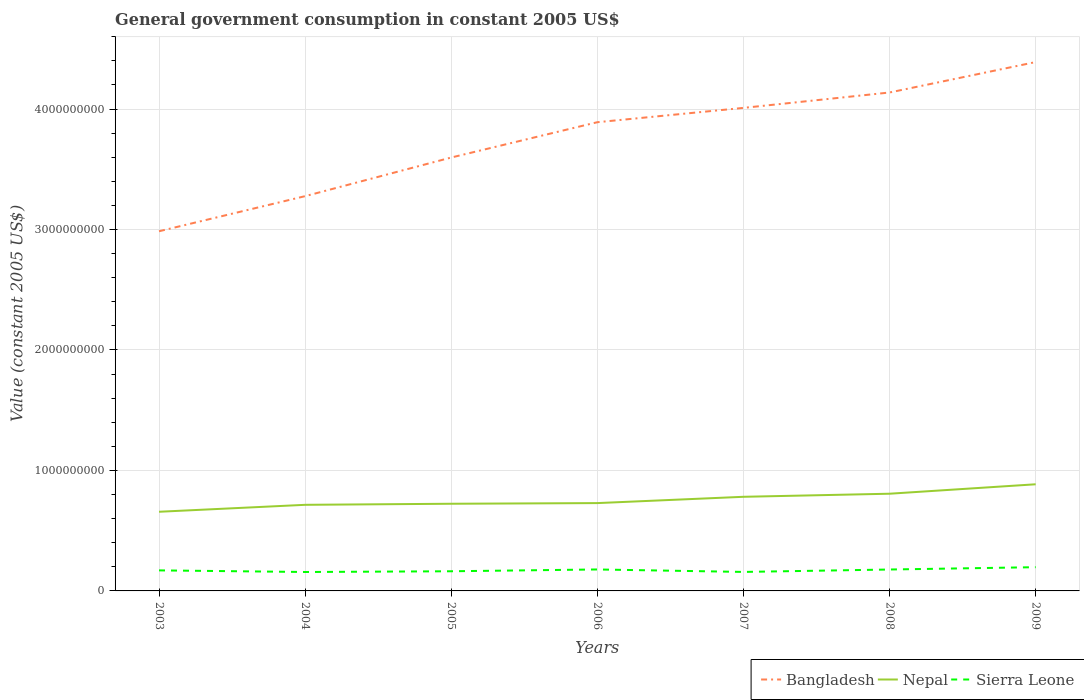Does the line corresponding to Bangladesh intersect with the line corresponding to Nepal?
Make the answer very short. No. Is the number of lines equal to the number of legend labels?
Your answer should be very brief. Yes. Across all years, what is the maximum government conusmption in Nepal?
Provide a succinct answer. 6.57e+08. In which year was the government conusmption in Sierra Leone maximum?
Your answer should be very brief. 2004. What is the total government conusmption in Sierra Leone in the graph?
Provide a succinct answer. -2.06e+07. What is the difference between the highest and the second highest government conusmption in Bangladesh?
Provide a short and direct response. 1.40e+09. Are the values on the major ticks of Y-axis written in scientific E-notation?
Make the answer very short. No. Does the graph contain any zero values?
Your answer should be very brief. No. Does the graph contain grids?
Your answer should be compact. Yes. Where does the legend appear in the graph?
Ensure brevity in your answer.  Bottom right. How many legend labels are there?
Make the answer very short. 3. What is the title of the graph?
Make the answer very short. General government consumption in constant 2005 US$. Does "Norway" appear as one of the legend labels in the graph?
Offer a terse response. No. What is the label or title of the X-axis?
Your answer should be very brief. Years. What is the label or title of the Y-axis?
Offer a very short reply. Value (constant 2005 US$). What is the Value (constant 2005 US$) of Bangladesh in 2003?
Give a very brief answer. 2.99e+09. What is the Value (constant 2005 US$) in Nepal in 2003?
Offer a terse response. 6.57e+08. What is the Value (constant 2005 US$) of Sierra Leone in 2003?
Your response must be concise. 1.70e+08. What is the Value (constant 2005 US$) in Bangladesh in 2004?
Ensure brevity in your answer.  3.28e+09. What is the Value (constant 2005 US$) of Nepal in 2004?
Give a very brief answer. 7.15e+08. What is the Value (constant 2005 US$) of Sierra Leone in 2004?
Offer a very short reply. 1.57e+08. What is the Value (constant 2005 US$) in Bangladesh in 2005?
Your answer should be compact. 3.60e+09. What is the Value (constant 2005 US$) in Nepal in 2005?
Ensure brevity in your answer.  7.24e+08. What is the Value (constant 2005 US$) of Sierra Leone in 2005?
Your response must be concise. 1.63e+08. What is the Value (constant 2005 US$) of Bangladesh in 2006?
Give a very brief answer. 3.89e+09. What is the Value (constant 2005 US$) of Nepal in 2006?
Offer a very short reply. 7.29e+08. What is the Value (constant 2005 US$) in Sierra Leone in 2006?
Offer a very short reply. 1.78e+08. What is the Value (constant 2005 US$) in Bangladesh in 2007?
Provide a succinct answer. 4.01e+09. What is the Value (constant 2005 US$) in Nepal in 2007?
Ensure brevity in your answer.  7.81e+08. What is the Value (constant 2005 US$) in Sierra Leone in 2007?
Your answer should be compact. 1.58e+08. What is the Value (constant 2005 US$) of Bangladesh in 2008?
Make the answer very short. 4.14e+09. What is the Value (constant 2005 US$) of Nepal in 2008?
Keep it short and to the point. 8.07e+08. What is the Value (constant 2005 US$) in Sierra Leone in 2008?
Your answer should be very brief. 1.78e+08. What is the Value (constant 2005 US$) in Bangladesh in 2009?
Your answer should be very brief. 4.39e+09. What is the Value (constant 2005 US$) of Nepal in 2009?
Your answer should be very brief. 8.85e+08. What is the Value (constant 2005 US$) of Sierra Leone in 2009?
Your response must be concise. 1.97e+08. Across all years, what is the maximum Value (constant 2005 US$) in Bangladesh?
Give a very brief answer. 4.39e+09. Across all years, what is the maximum Value (constant 2005 US$) in Nepal?
Provide a succinct answer. 8.85e+08. Across all years, what is the maximum Value (constant 2005 US$) of Sierra Leone?
Your answer should be very brief. 1.97e+08. Across all years, what is the minimum Value (constant 2005 US$) in Bangladesh?
Your answer should be compact. 2.99e+09. Across all years, what is the minimum Value (constant 2005 US$) in Nepal?
Give a very brief answer. 6.57e+08. Across all years, what is the minimum Value (constant 2005 US$) in Sierra Leone?
Provide a succinct answer. 1.57e+08. What is the total Value (constant 2005 US$) in Bangladesh in the graph?
Your response must be concise. 2.63e+1. What is the total Value (constant 2005 US$) of Nepal in the graph?
Ensure brevity in your answer.  5.30e+09. What is the total Value (constant 2005 US$) in Sierra Leone in the graph?
Ensure brevity in your answer.  1.20e+09. What is the difference between the Value (constant 2005 US$) in Bangladesh in 2003 and that in 2004?
Provide a succinct answer. -2.91e+08. What is the difference between the Value (constant 2005 US$) in Nepal in 2003 and that in 2004?
Provide a succinct answer. -5.77e+07. What is the difference between the Value (constant 2005 US$) in Sierra Leone in 2003 and that in 2004?
Your response must be concise. 1.34e+07. What is the difference between the Value (constant 2005 US$) in Bangladesh in 2003 and that in 2005?
Give a very brief answer. -6.12e+08. What is the difference between the Value (constant 2005 US$) in Nepal in 2003 and that in 2005?
Offer a very short reply. -6.66e+07. What is the difference between the Value (constant 2005 US$) of Sierra Leone in 2003 and that in 2005?
Ensure brevity in your answer.  7.30e+06. What is the difference between the Value (constant 2005 US$) in Bangladesh in 2003 and that in 2006?
Offer a terse response. -9.05e+08. What is the difference between the Value (constant 2005 US$) of Nepal in 2003 and that in 2006?
Your answer should be compact. -7.20e+07. What is the difference between the Value (constant 2005 US$) in Sierra Leone in 2003 and that in 2006?
Your answer should be very brief. -7.66e+06. What is the difference between the Value (constant 2005 US$) in Bangladesh in 2003 and that in 2007?
Ensure brevity in your answer.  -1.02e+09. What is the difference between the Value (constant 2005 US$) in Nepal in 2003 and that in 2007?
Your response must be concise. -1.24e+08. What is the difference between the Value (constant 2005 US$) in Sierra Leone in 2003 and that in 2007?
Offer a terse response. 1.28e+07. What is the difference between the Value (constant 2005 US$) of Bangladesh in 2003 and that in 2008?
Ensure brevity in your answer.  -1.15e+09. What is the difference between the Value (constant 2005 US$) in Nepal in 2003 and that in 2008?
Your answer should be compact. -1.50e+08. What is the difference between the Value (constant 2005 US$) in Sierra Leone in 2003 and that in 2008?
Provide a succinct answer. -7.21e+06. What is the difference between the Value (constant 2005 US$) in Bangladesh in 2003 and that in 2009?
Offer a terse response. -1.40e+09. What is the difference between the Value (constant 2005 US$) in Nepal in 2003 and that in 2009?
Offer a terse response. -2.28e+08. What is the difference between the Value (constant 2005 US$) in Sierra Leone in 2003 and that in 2009?
Make the answer very short. -2.65e+07. What is the difference between the Value (constant 2005 US$) of Bangladesh in 2004 and that in 2005?
Offer a very short reply. -3.21e+08. What is the difference between the Value (constant 2005 US$) in Nepal in 2004 and that in 2005?
Keep it short and to the point. -8.87e+06. What is the difference between the Value (constant 2005 US$) in Sierra Leone in 2004 and that in 2005?
Your answer should be compact. -6.08e+06. What is the difference between the Value (constant 2005 US$) in Bangladesh in 2004 and that in 2006?
Your answer should be compact. -6.14e+08. What is the difference between the Value (constant 2005 US$) in Nepal in 2004 and that in 2006?
Provide a short and direct response. -1.43e+07. What is the difference between the Value (constant 2005 US$) of Sierra Leone in 2004 and that in 2006?
Ensure brevity in your answer.  -2.11e+07. What is the difference between the Value (constant 2005 US$) of Bangladesh in 2004 and that in 2007?
Offer a terse response. -7.33e+08. What is the difference between the Value (constant 2005 US$) of Nepal in 2004 and that in 2007?
Offer a terse response. -6.66e+07. What is the difference between the Value (constant 2005 US$) of Sierra Leone in 2004 and that in 2007?
Give a very brief answer. -5.56e+05. What is the difference between the Value (constant 2005 US$) of Bangladesh in 2004 and that in 2008?
Provide a succinct answer. -8.60e+08. What is the difference between the Value (constant 2005 US$) of Nepal in 2004 and that in 2008?
Ensure brevity in your answer.  -9.21e+07. What is the difference between the Value (constant 2005 US$) in Sierra Leone in 2004 and that in 2008?
Give a very brief answer. -2.06e+07. What is the difference between the Value (constant 2005 US$) in Bangladesh in 2004 and that in 2009?
Offer a very short reply. -1.11e+09. What is the difference between the Value (constant 2005 US$) of Nepal in 2004 and that in 2009?
Ensure brevity in your answer.  -1.70e+08. What is the difference between the Value (constant 2005 US$) in Sierra Leone in 2004 and that in 2009?
Keep it short and to the point. -3.99e+07. What is the difference between the Value (constant 2005 US$) in Bangladesh in 2005 and that in 2006?
Keep it short and to the point. -2.93e+08. What is the difference between the Value (constant 2005 US$) of Nepal in 2005 and that in 2006?
Your answer should be compact. -5.47e+06. What is the difference between the Value (constant 2005 US$) of Sierra Leone in 2005 and that in 2006?
Provide a short and direct response. -1.50e+07. What is the difference between the Value (constant 2005 US$) of Bangladesh in 2005 and that in 2007?
Ensure brevity in your answer.  -4.12e+08. What is the difference between the Value (constant 2005 US$) of Nepal in 2005 and that in 2007?
Your response must be concise. -5.77e+07. What is the difference between the Value (constant 2005 US$) in Sierra Leone in 2005 and that in 2007?
Provide a succinct answer. 5.53e+06. What is the difference between the Value (constant 2005 US$) of Bangladesh in 2005 and that in 2008?
Provide a succinct answer. -5.40e+08. What is the difference between the Value (constant 2005 US$) of Nepal in 2005 and that in 2008?
Give a very brief answer. -8.33e+07. What is the difference between the Value (constant 2005 US$) in Sierra Leone in 2005 and that in 2008?
Provide a short and direct response. -1.45e+07. What is the difference between the Value (constant 2005 US$) of Bangladesh in 2005 and that in 2009?
Your answer should be very brief. -7.92e+08. What is the difference between the Value (constant 2005 US$) of Nepal in 2005 and that in 2009?
Offer a very short reply. -1.62e+08. What is the difference between the Value (constant 2005 US$) in Sierra Leone in 2005 and that in 2009?
Ensure brevity in your answer.  -3.38e+07. What is the difference between the Value (constant 2005 US$) in Bangladesh in 2006 and that in 2007?
Give a very brief answer. -1.19e+08. What is the difference between the Value (constant 2005 US$) of Nepal in 2006 and that in 2007?
Ensure brevity in your answer.  -5.22e+07. What is the difference between the Value (constant 2005 US$) of Sierra Leone in 2006 and that in 2007?
Keep it short and to the point. 2.05e+07. What is the difference between the Value (constant 2005 US$) of Bangladesh in 2006 and that in 2008?
Give a very brief answer. -2.47e+08. What is the difference between the Value (constant 2005 US$) of Nepal in 2006 and that in 2008?
Keep it short and to the point. -7.78e+07. What is the difference between the Value (constant 2005 US$) in Sierra Leone in 2006 and that in 2008?
Offer a terse response. 4.51e+05. What is the difference between the Value (constant 2005 US$) of Bangladesh in 2006 and that in 2009?
Provide a short and direct response. -4.99e+08. What is the difference between the Value (constant 2005 US$) of Nepal in 2006 and that in 2009?
Give a very brief answer. -1.56e+08. What is the difference between the Value (constant 2005 US$) of Sierra Leone in 2006 and that in 2009?
Your response must be concise. -1.89e+07. What is the difference between the Value (constant 2005 US$) of Bangladesh in 2007 and that in 2008?
Provide a succinct answer. -1.28e+08. What is the difference between the Value (constant 2005 US$) of Nepal in 2007 and that in 2008?
Make the answer very short. -2.56e+07. What is the difference between the Value (constant 2005 US$) in Sierra Leone in 2007 and that in 2008?
Offer a terse response. -2.00e+07. What is the difference between the Value (constant 2005 US$) of Bangladesh in 2007 and that in 2009?
Offer a terse response. -3.80e+08. What is the difference between the Value (constant 2005 US$) of Nepal in 2007 and that in 2009?
Your answer should be very brief. -1.04e+08. What is the difference between the Value (constant 2005 US$) of Sierra Leone in 2007 and that in 2009?
Your answer should be very brief. -3.93e+07. What is the difference between the Value (constant 2005 US$) of Bangladesh in 2008 and that in 2009?
Your answer should be very brief. -2.52e+08. What is the difference between the Value (constant 2005 US$) in Nepal in 2008 and that in 2009?
Your answer should be very brief. -7.83e+07. What is the difference between the Value (constant 2005 US$) of Sierra Leone in 2008 and that in 2009?
Ensure brevity in your answer.  -1.93e+07. What is the difference between the Value (constant 2005 US$) in Bangladesh in 2003 and the Value (constant 2005 US$) in Nepal in 2004?
Offer a terse response. 2.27e+09. What is the difference between the Value (constant 2005 US$) of Bangladesh in 2003 and the Value (constant 2005 US$) of Sierra Leone in 2004?
Provide a short and direct response. 2.83e+09. What is the difference between the Value (constant 2005 US$) in Nepal in 2003 and the Value (constant 2005 US$) in Sierra Leone in 2004?
Your answer should be compact. 5.00e+08. What is the difference between the Value (constant 2005 US$) of Bangladesh in 2003 and the Value (constant 2005 US$) of Nepal in 2005?
Make the answer very short. 2.26e+09. What is the difference between the Value (constant 2005 US$) of Bangladesh in 2003 and the Value (constant 2005 US$) of Sierra Leone in 2005?
Your answer should be very brief. 2.82e+09. What is the difference between the Value (constant 2005 US$) of Nepal in 2003 and the Value (constant 2005 US$) of Sierra Leone in 2005?
Provide a succinct answer. 4.94e+08. What is the difference between the Value (constant 2005 US$) in Bangladesh in 2003 and the Value (constant 2005 US$) in Nepal in 2006?
Offer a terse response. 2.26e+09. What is the difference between the Value (constant 2005 US$) in Bangladesh in 2003 and the Value (constant 2005 US$) in Sierra Leone in 2006?
Offer a terse response. 2.81e+09. What is the difference between the Value (constant 2005 US$) in Nepal in 2003 and the Value (constant 2005 US$) in Sierra Leone in 2006?
Give a very brief answer. 4.79e+08. What is the difference between the Value (constant 2005 US$) of Bangladesh in 2003 and the Value (constant 2005 US$) of Nepal in 2007?
Your answer should be very brief. 2.20e+09. What is the difference between the Value (constant 2005 US$) in Bangladesh in 2003 and the Value (constant 2005 US$) in Sierra Leone in 2007?
Ensure brevity in your answer.  2.83e+09. What is the difference between the Value (constant 2005 US$) in Nepal in 2003 and the Value (constant 2005 US$) in Sierra Leone in 2007?
Make the answer very short. 4.99e+08. What is the difference between the Value (constant 2005 US$) in Bangladesh in 2003 and the Value (constant 2005 US$) in Nepal in 2008?
Provide a short and direct response. 2.18e+09. What is the difference between the Value (constant 2005 US$) of Bangladesh in 2003 and the Value (constant 2005 US$) of Sierra Leone in 2008?
Keep it short and to the point. 2.81e+09. What is the difference between the Value (constant 2005 US$) in Nepal in 2003 and the Value (constant 2005 US$) in Sierra Leone in 2008?
Provide a succinct answer. 4.79e+08. What is the difference between the Value (constant 2005 US$) in Bangladesh in 2003 and the Value (constant 2005 US$) in Nepal in 2009?
Your answer should be very brief. 2.10e+09. What is the difference between the Value (constant 2005 US$) of Bangladesh in 2003 and the Value (constant 2005 US$) of Sierra Leone in 2009?
Make the answer very short. 2.79e+09. What is the difference between the Value (constant 2005 US$) of Nepal in 2003 and the Value (constant 2005 US$) of Sierra Leone in 2009?
Your answer should be compact. 4.60e+08. What is the difference between the Value (constant 2005 US$) in Bangladesh in 2004 and the Value (constant 2005 US$) in Nepal in 2005?
Provide a succinct answer. 2.55e+09. What is the difference between the Value (constant 2005 US$) in Bangladesh in 2004 and the Value (constant 2005 US$) in Sierra Leone in 2005?
Offer a terse response. 3.11e+09. What is the difference between the Value (constant 2005 US$) in Nepal in 2004 and the Value (constant 2005 US$) in Sierra Leone in 2005?
Ensure brevity in your answer.  5.51e+08. What is the difference between the Value (constant 2005 US$) in Bangladesh in 2004 and the Value (constant 2005 US$) in Nepal in 2006?
Give a very brief answer. 2.55e+09. What is the difference between the Value (constant 2005 US$) in Bangladesh in 2004 and the Value (constant 2005 US$) in Sierra Leone in 2006?
Provide a succinct answer. 3.10e+09. What is the difference between the Value (constant 2005 US$) of Nepal in 2004 and the Value (constant 2005 US$) of Sierra Leone in 2006?
Your answer should be very brief. 5.37e+08. What is the difference between the Value (constant 2005 US$) of Bangladesh in 2004 and the Value (constant 2005 US$) of Nepal in 2007?
Ensure brevity in your answer.  2.50e+09. What is the difference between the Value (constant 2005 US$) in Bangladesh in 2004 and the Value (constant 2005 US$) in Sierra Leone in 2007?
Provide a succinct answer. 3.12e+09. What is the difference between the Value (constant 2005 US$) in Nepal in 2004 and the Value (constant 2005 US$) in Sierra Leone in 2007?
Keep it short and to the point. 5.57e+08. What is the difference between the Value (constant 2005 US$) of Bangladesh in 2004 and the Value (constant 2005 US$) of Nepal in 2008?
Make the answer very short. 2.47e+09. What is the difference between the Value (constant 2005 US$) of Bangladesh in 2004 and the Value (constant 2005 US$) of Sierra Leone in 2008?
Your answer should be very brief. 3.10e+09. What is the difference between the Value (constant 2005 US$) of Nepal in 2004 and the Value (constant 2005 US$) of Sierra Leone in 2008?
Your answer should be compact. 5.37e+08. What is the difference between the Value (constant 2005 US$) of Bangladesh in 2004 and the Value (constant 2005 US$) of Nepal in 2009?
Ensure brevity in your answer.  2.39e+09. What is the difference between the Value (constant 2005 US$) of Bangladesh in 2004 and the Value (constant 2005 US$) of Sierra Leone in 2009?
Ensure brevity in your answer.  3.08e+09. What is the difference between the Value (constant 2005 US$) of Nepal in 2004 and the Value (constant 2005 US$) of Sierra Leone in 2009?
Ensure brevity in your answer.  5.18e+08. What is the difference between the Value (constant 2005 US$) in Bangladesh in 2005 and the Value (constant 2005 US$) in Nepal in 2006?
Your response must be concise. 2.87e+09. What is the difference between the Value (constant 2005 US$) of Bangladesh in 2005 and the Value (constant 2005 US$) of Sierra Leone in 2006?
Your answer should be compact. 3.42e+09. What is the difference between the Value (constant 2005 US$) in Nepal in 2005 and the Value (constant 2005 US$) in Sierra Leone in 2006?
Keep it short and to the point. 5.45e+08. What is the difference between the Value (constant 2005 US$) in Bangladesh in 2005 and the Value (constant 2005 US$) in Nepal in 2007?
Provide a short and direct response. 2.82e+09. What is the difference between the Value (constant 2005 US$) in Bangladesh in 2005 and the Value (constant 2005 US$) in Sierra Leone in 2007?
Provide a short and direct response. 3.44e+09. What is the difference between the Value (constant 2005 US$) in Nepal in 2005 and the Value (constant 2005 US$) in Sierra Leone in 2007?
Make the answer very short. 5.66e+08. What is the difference between the Value (constant 2005 US$) of Bangladesh in 2005 and the Value (constant 2005 US$) of Nepal in 2008?
Provide a succinct answer. 2.79e+09. What is the difference between the Value (constant 2005 US$) of Bangladesh in 2005 and the Value (constant 2005 US$) of Sierra Leone in 2008?
Your response must be concise. 3.42e+09. What is the difference between the Value (constant 2005 US$) of Nepal in 2005 and the Value (constant 2005 US$) of Sierra Leone in 2008?
Give a very brief answer. 5.46e+08. What is the difference between the Value (constant 2005 US$) in Bangladesh in 2005 and the Value (constant 2005 US$) in Nepal in 2009?
Make the answer very short. 2.71e+09. What is the difference between the Value (constant 2005 US$) of Bangladesh in 2005 and the Value (constant 2005 US$) of Sierra Leone in 2009?
Make the answer very short. 3.40e+09. What is the difference between the Value (constant 2005 US$) in Nepal in 2005 and the Value (constant 2005 US$) in Sierra Leone in 2009?
Offer a very short reply. 5.27e+08. What is the difference between the Value (constant 2005 US$) in Bangladesh in 2006 and the Value (constant 2005 US$) in Nepal in 2007?
Provide a succinct answer. 3.11e+09. What is the difference between the Value (constant 2005 US$) in Bangladesh in 2006 and the Value (constant 2005 US$) in Sierra Leone in 2007?
Offer a very short reply. 3.73e+09. What is the difference between the Value (constant 2005 US$) in Nepal in 2006 and the Value (constant 2005 US$) in Sierra Leone in 2007?
Your answer should be very brief. 5.71e+08. What is the difference between the Value (constant 2005 US$) of Bangladesh in 2006 and the Value (constant 2005 US$) of Nepal in 2008?
Provide a short and direct response. 3.08e+09. What is the difference between the Value (constant 2005 US$) in Bangladesh in 2006 and the Value (constant 2005 US$) in Sierra Leone in 2008?
Keep it short and to the point. 3.71e+09. What is the difference between the Value (constant 2005 US$) of Nepal in 2006 and the Value (constant 2005 US$) of Sierra Leone in 2008?
Your answer should be very brief. 5.51e+08. What is the difference between the Value (constant 2005 US$) of Bangladesh in 2006 and the Value (constant 2005 US$) of Nepal in 2009?
Your response must be concise. 3.01e+09. What is the difference between the Value (constant 2005 US$) in Bangladesh in 2006 and the Value (constant 2005 US$) in Sierra Leone in 2009?
Ensure brevity in your answer.  3.69e+09. What is the difference between the Value (constant 2005 US$) in Nepal in 2006 and the Value (constant 2005 US$) in Sierra Leone in 2009?
Your answer should be compact. 5.32e+08. What is the difference between the Value (constant 2005 US$) in Bangladesh in 2007 and the Value (constant 2005 US$) in Nepal in 2008?
Your answer should be very brief. 3.20e+09. What is the difference between the Value (constant 2005 US$) in Bangladesh in 2007 and the Value (constant 2005 US$) in Sierra Leone in 2008?
Ensure brevity in your answer.  3.83e+09. What is the difference between the Value (constant 2005 US$) of Nepal in 2007 and the Value (constant 2005 US$) of Sierra Leone in 2008?
Provide a short and direct response. 6.04e+08. What is the difference between the Value (constant 2005 US$) of Bangladesh in 2007 and the Value (constant 2005 US$) of Nepal in 2009?
Provide a short and direct response. 3.12e+09. What is the difference between the Value (constant 2005 US$) of Bangladesh in 2007 and the Value (constant 2005 US$) of Sierra Leone in 2009?
Make the answer very short. 3.81e+09. What is the difference between the Value (constant 2005 US$) in Nepal in 2007 and the Value (constant 2005 US$) in Sierra Leone in 2009?
Make the answer very short. 5.84e+08. What is the difference between the Value (constant 2005 US$) in Bangladesh in 2008 and the Value (constant 2005 US$) in Nepal in 2009?
Provide a succinct answer. 3.25e+09. What is the difference between the Value (constant 2005 US$) of Bangladesh in 2008 and the Value (constant 2005 US$) of Sierra Leone in 2009?
Give a very brief answer. 3.94e+09. What is the difference between the Value (constant 2005 US$) in Nepal in 2008 and the Value (constant 2005 US$) in Sierra Leone in 2009?
Provide a short and direct response. 6.10e+08. What is the average Value (constant 2005 US$) in Bangladesh per year?
Your response must be concise. 3.76e+09. What is the average Value (constant 2005 US$) in Nepal per year?
Your answer should be compact. 7.57e+08. What is the average Value (constant 2005 US$) of Sierra Leone per year?
Your answer should be compact. 1.72e+08. In the year 2003, what is the difference between the Value (constant 2005 US$) of Bangladesh and Value (constant 2005 US$) of Nepal?
Your answer should be compact. 2.33e+09. In the year 2003, what is the difference between the Value (constant 2005 US$) in Bangladesh and Value (constant 2005 US$) in Sierra Leone?
Provide a succinct answer. 2.81e+09. In the year 2003, what is the difference between the Value (constant 2005 US$) of Nepal and Value (constant 2005 US$) of Sierra Leone?
Give a very brief answer. 4.86e+08. In the year 2004, what is the difference between the Value (constant 2005 US$) in Bangladesh and Value (constant 2005 US$) in Nepal?
Your response must be concise. 2.56e+09. In the year 2004, what is the difference between the Value (constant 2005 US$) of Bangladesh and Value (constant 2005 US$) of Sierra Leone?
Make the answer very short. 3.12e+09. In the year 2004, what is the difference between the Value (constant 2005 US$) of Nepal and Value (constant 2005 US$) of Sierra Leone?
Your response must be concise. 5.58e+08. In the year 2005, what is the difference between the Value (constant 2005 US$) of Bangladesh and Value (constant 2005 US$) of Nepal?
Give a very brief answer. 2.87e+09. In the year 2005, what is the difference between the Value (constant 2005 US$) of Bangladesh and Value (constant 2005 US$) of Sierra Leone?
Your answer should be very brief. 3.43e+09. In the year 2005, what is the difference between the Value (constant 2005 US$) of Nepal and Value (constant 2005 US$) of Sierra Leone?
Your answer should be compact. 5.60e+08. In the year 2006, what is the difference between the Value (constant 2005 US$) of Bangladesh and Value (constant 2005 US$) of Nepal?
Ensure brevity in your answer.  3.16e+09. In the year 2006, what is the difference between the Value (constant 2005 US$) in Bangladesh and Value (constant 2005 US$) in Sierra Leone?
Ensure brevity in your answer.  3.71e+09. In the year 2006, what is the difference between the Value (constant 2005 US$) in Nepal and Value (constant 2005 US$) in Sierra Leone?
Provide a succinct answer. 5.51e+08. In the year 2007, what is the difference between the Value (constant 2005 US$) of Bangladesh and Value (constant 2005 US$) of Nepal?
Make the answer very short. 3.23e+09. In the year 2007, what is the difference between the Value (constant 2005 US$) of Bangladesh and Value (constant 2005 US$) of Sierra Leone?
Your answer should be very brief. 3.85e+09. In the year 2007, what is the difference between the Value (constant 2005 US$) of Nepal and Value (constant 2005 US$) of Sierra Leone?
Offer a very short reply. 6.24e+08. In the year 2008, what is the difference between the Value (constant 2005 US$) of Bangladesh and Value (constant 2005 US$) of Nepal?
Offer a terse response. 3.33e+09. In the year 2008, what is the difference between the Value (constant 2005 US$) in Bangladesh and Value (constant 2005 US$) in Sierra Leone?
Offer a very short reply. 3.96e+09. In the year 2008, what is the difference between the Value (constant 2005 US$) in Nepal and Value (constant 2005 US$) in Sierra Leone?
Provide a succinct answer. 6.29e+08. In the year 2009, what is the difference between the Value (constant 2005 US$) of Bangladesh and Value (constant 2005 US$) of Nepal?
Provide a short and direct response. 3.50e+09. In the year 2009, what is the difference between the Value (constant 2005 US$) in Bangladesh and Value (constant 2005 US$) in Sierra Leone?
Make the answer very short. 4.19e+09. In the year 2009, what is the difference between the Value (constant 2005 US$) of Nepal and Value (constant 2005 US$) of Sierra Leone?
Ensure brevity in your answer.  6.88e+08. What is the ratio of the Value (constant 2005 US$) in Bangladesh in 2003 to that in 2004?
Offer a very short reply. 0.91. What is the ratio of the Value (constant 2005 US$) of Nepal in 2003 to that in 2004?
Provide a succinct answer. 0.92. What is the ratio of the Value (constant 2005 US$) of Sierra Leone in 2003 to that in 2004?
Provide a succinct answer. 1.09. What is the ratio of the Value (constant 2005 US$) in Bangladesh in 2003 to that in 2005?
Offer a very short reply. 0.83. What is the ratio of the Value (constant 2005 US$) in Nepal in 2003 to that in 2005?
Ensure brevity in your answer.  0.91. What is the ratio of the Value (constant 2005 US$) of Sierra Leone in 2003 to that in 2005?
Ensure brevity in your answer.  1.04. What is the ratio of the Value (constant 2005 US$) of Bangladesh in 2003 to that in 2006?
Provide a short and direct response. 0.77. What is the ratio of the Value (constant 2005 US$) in Nepal in 2003 to that in 2006?
Give a very brief answer. 0.9. What is the ratio of the Value (constant 2005 US$) of Sierra Leone in 2003 to that in 2006?
Your answer should be very brief. 0.96. What is the ratio of the Value (constant 2005 US$) in Bangladesh in 2003 to that in 2007?
Your answer should be compact. 0.74. What is the ratio of the Value (constant 2005 US$) of Nepal in 2003 to that in 2007?
Your response must be concise. 0.84. What is the ratio of the Value (constant 2005 US$) of Sierra Leone in 2003 to that in 2007?
Offer a very short reply. 1.08. What is the ratio of the Value (constant 2005 US$) of Bangladesh in 2003 to that in 2008?
Your answer should be very brief. 0.72. What is the ratio of the Value (constant 2005 US$) in Nepal in 2003 to that in 2008?
Offer a very short reply. 0.81. What is the ratio of the Value (constant 2005 US$) of Sierra Leone in 2003 to that in 2008?
Keep it short and to the point. 0.96. What is the ratio of the Value (constant 2005 US$) in Bangladesh in 2003 to that in 2009?
Ensure brevity in your answer.  0.68. What is the ratio of the Value (constant 2005 US$) in Nepal in 2003 to that in 2009?
Your answer should be very brief. 0.74. What is the ratio of the Value (constant 2005 US$) of Sierra Leone in 2003 to that in 2009?
Offer a terse response. 0.87. What is the ratio of the Value (constant 2005 US$) of Bangladesh in 2004 to that in 2005?
Make the answer very short. 0.91. What is the ratio of the Value (constant 2005 US$) in Nepal in 2004 to that in 2005?
Give a very brief answer. 0.99. What is the ratio of the Value (constant 2005 US$) of Sierra Leone in 2004 to that in 2005?
Provide a short and direct response. 0.96. What is the ratio of the Value (constant 2005 US$) in Bangladesh in 2004 to that in 2006?
Provide a short and direct response. 0.84. What is the ratio of the Value (constant 2005 US$) of Nepal in 2004 to that in 2006?
Provide a short and direct response. 0.98. What is the ratio of the Value (constant 2005 US$) of Sierra Leone in 2004 to that in 2006?
Your response must be concise. 0.88. What is the ratio of the Value (constant 2005 US$) of Bangladesh in 2004 to that in 2007?
Your answer should be very brief. 0.82. What is the ratio of the Value (constant 2005 US$) in Nepal in 2004 to that in 2007?
Your answer should be compact. 0.91. What is the ratio of the Value (constant 2005 US$) of Sierra Leone in 2004 to that in 2007?
Offer a terse response. 1. What is the ratio of the Value (constant 2005 US$) in Bangladesh in 2004 to that in 2008?
Ensure brevity in your answer.  0.79. What is the ratio of the Value (constant 2005 US$) of Nepal in 2004 to that in 2008?
Make the answer very short. 0.89. What is the ratio of the Value (constant 2005 US$) in Sierra Leone in 2004 to that in 2008?
Make the answer very short. 0.88. What is the ratio of the Value (constant 2005 US$) of Bangladesh in 2004 to that in 2009?
Ensure brevity in your answer.  0.75. What is the ratio of the Value (constant 2005 US$) in Nepal in 2004 to that in 2009?
Make the answer very short. 0.81. What is the ratio of the Value (constant 2005 US$) in Sierra Leone in 2004 to that in 2009?
Provide a succinct answer. 0.8. What is the ratio of the Value (constant 2005 US$) of Bangladesh in 2005 to that in 2006?
Your answer should be very brief. 0.92. What is the ratio of the Value (constant 2005 US$) of Sierra Leone in 2005 to that in 2006?
Offer a terse response. 0.92. What is the ratio of the Value (constant 2005 US$) in Bangladesh in 2005 to that in 2007?
Your answer should be very brief. 0.9. What is the ratio of the Value (constant 2005 US$) in Nepal in 2005 to that in 2007?
Keep it short and to the point. 0.93. What is the ratio of the Value (constant 2005 US$) in Sierra Leone in 2005 to that in 2007?
Provide a short and direct response. 1.04. What is the ratio of the Value (constant 2005 US$) in Bangladesh in 2005 to that in 2008?
Keep it short and to the point. 0.87. What is the ratio of the Value (constant 2005 US$) in Nepal in 2005 to that in 2008?
Keep it short and to the point. 0.9. What is the ratio of the Value (constant 2005 US$) in Sierra Leone in 2005 to that in 2008?
Offer a very short reply. 0.92. What is the ratio of the Value (constant 2005 US$) in Bangladesh in 2005 to that in 2009?
Keep it short and to the point. 0.82. What is the ratio of the Value (constant 2005 US$) in Nepal in 2005 to that in 2009?
Your answer should be compact. 0.82. What is the ratio of the Value (constant 2005 US$) in Sierra Leone in 2005 to that in 2009?
Offer a very short reply. 0.83. What is the ratio of the Value (constant 2005 US$) of Bangladesh in 2006 to that in 2007?
Your answer should be compact. 0.97. What is the ratio of the Value (constant 2005 US$) of Nepal in 2006 to that in 2007?
Keep it short and to the point. 0.93. What is the ratio of the Value (constant 2005 US$) of Sierra Leone in 2006 to that in 2007?
Give a very brief answer. 1.13. What is the ratio of the Value (constant 2005 US$) in Bangladesh in 2006 to that in 2008?
Offer a very short reply. 0.94. What is the ratio of the Value (constant 2005 US$) in Nepal in 2006 to that in 2008?
Ensure brevity in your answer.  0.9. What is the ratio of the Value (constant 2005 US$) in Sierra Leone in 2006 to that in 2008?
Provide a short and direct response. 1. What is the ratio of the Value (constant 2005 US$) of Bangladesh in 2006 to that in 2009?
Your answer should be compact. 0.89. What is the ratio of the Value (constant 2005 US$) in Nepal in 2006 to that in 2009?
Your answer should be very brief. 0.82. What is the ratio of the Value (constant 2005 US$) in Sierra Leone in 2006 to that in 2009?
Offer a very short reply. 0.9. What is the ratio of the Value (constant 2005 US$) of Bangladesh in 2007 to that in 2008?
Your response must be concise. 0.97. What is the ratio of the Value (constant 2005 US$) in Nepal in 2007 to that in 2008?
Your answer should be very brief. 0.97. What is the ratio of the Value (constant 2005 US$) in Sierra Leone in 2007 to that in 2008?
Offer a terse response. 0.89. What is the ratio of the Value (constant 2005 US$) in Bangladesh in 2007 to that in 2009?
Give a very brief answer. 0.91. What is the ratio of the Value (constant 2005 US$) of Nepal in 2007 to that in 2009?
Ensure brevity in your answer.  0.88. What is the ratio of the Value (constant 2005 US$) in Sierra Leone in 2007 to that in 2009?
Your answer should be compact. 0.8. What is the ratio of the Value (constant 2005 US$) of Bangladesh in 2008 to that in 2009?
Your answer should be very brief. 0.94. What is the ratio of the Value (constant 2005 US$) of Nepal in 2008 to that in 2009?
Make the answer very short. 0.91. What is the ratio of the Value (constant 2005 US$) of Sierra Leone in 2008 to that in 2009?
Your answer should be compact. 0.9. What is the difference between the highest and the second highest Value (constant 2005 US$) of Bangladesh?
Ensure brevity in your answer.  2.52e+08. What is the difference between the highest and the second highest Value (constant 2005 US$) of Nepal?
Ensure brevity in your answer.  7.83e+07. What is the difference between the highest and the second highest Value (constant 2005 US$) of Sierra Leone?
Your response must be concise. 1.89e+07. What is the difference between the highest and the lowest Value (constant 2005 US$) of Bangladesh?
Give a very brief answer. 1.40e+09. What is the difference between the highest and the lowest Value (constant 2005 US$) in Nepal?
Provide a short and direct response. 2.28e+08. What is the difference between the highest and the lowest Value (constant 2005 US$) of Sierra Leone?
Provide a succinct answer. 3.99e+07. 